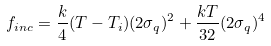Convert formula to latex. <formula><loc_0><loc_0><loc_500><loc_500>f _ { i n c } = \frac { k } { 4 } ( T - T _ { i } ) ( 2 \sigma _ { q } ) ^ { 2 } + \frac { k T } { 3 2 } ( 2 \sigma _ { q } ) ^ { 4 }</formula> 